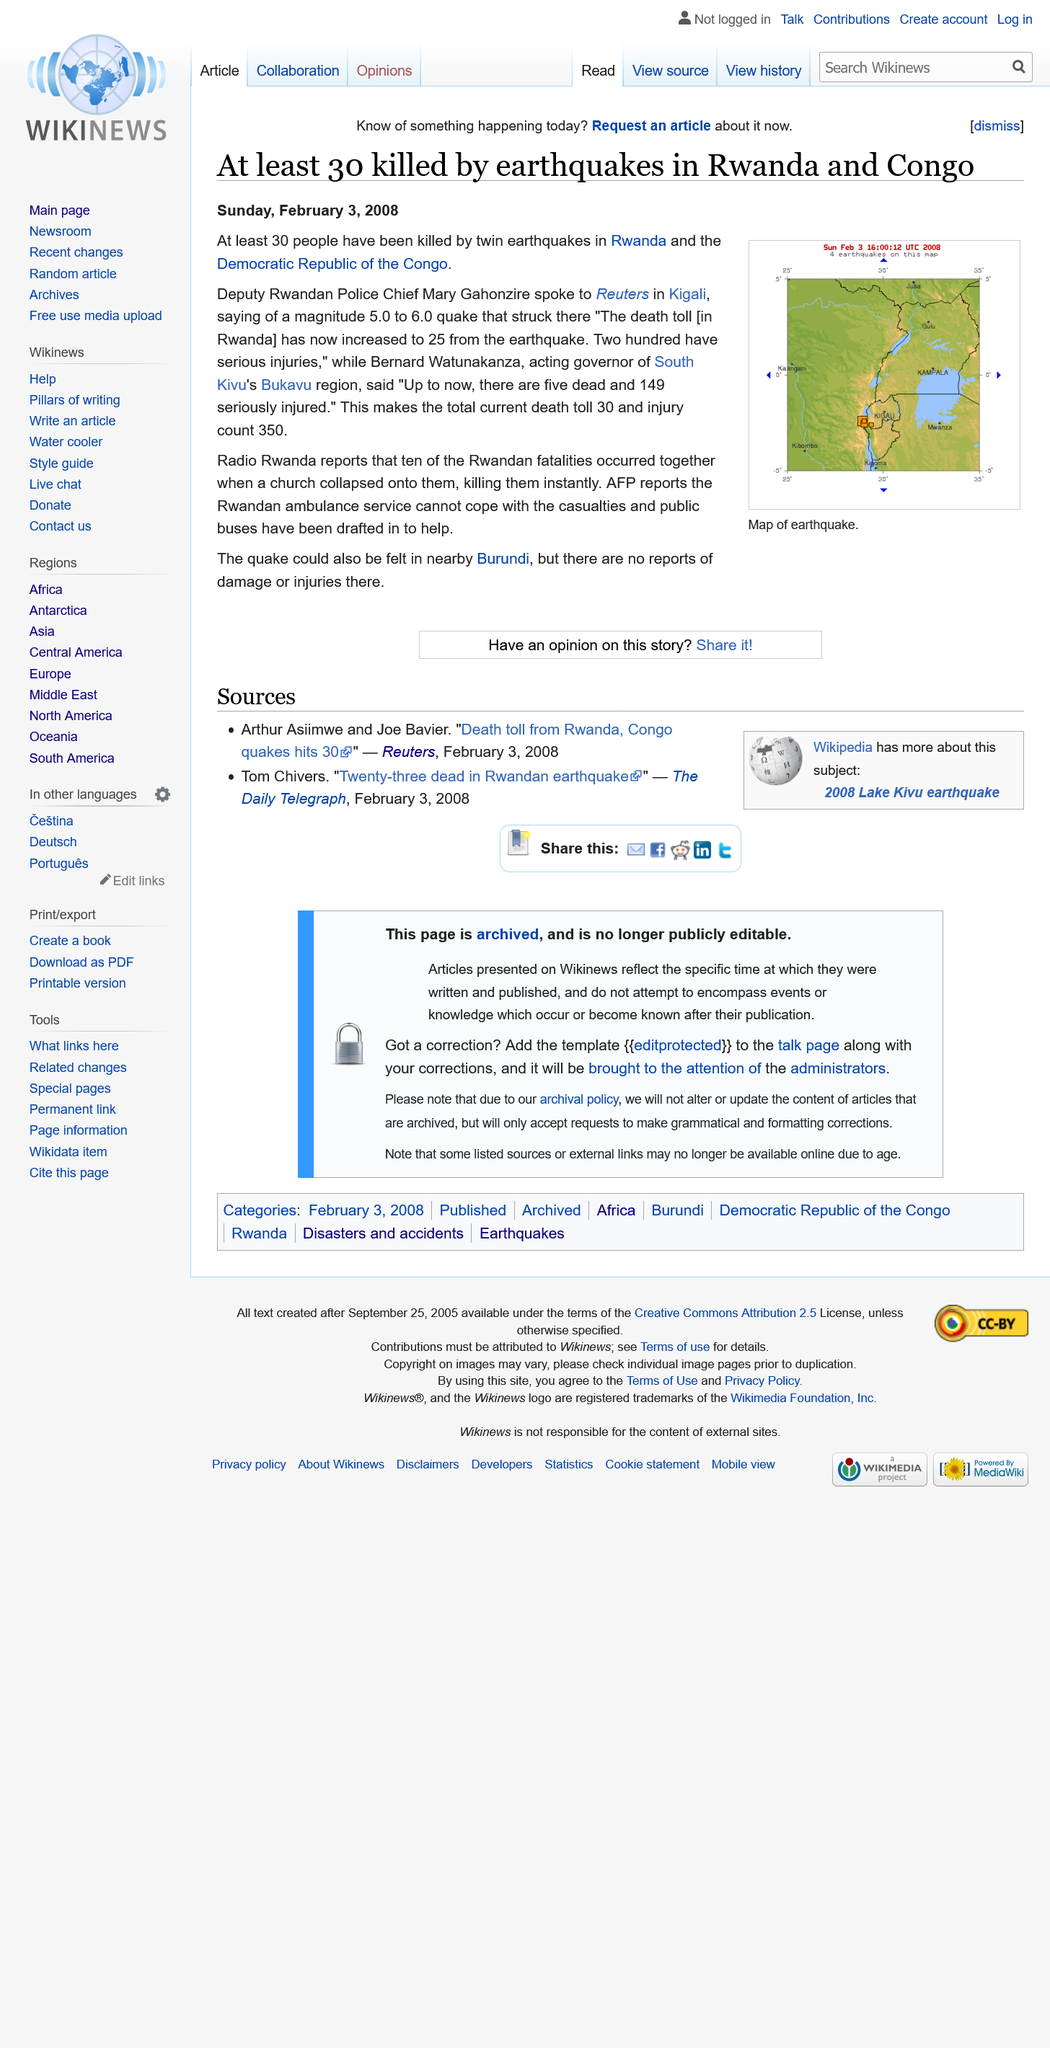Identify some key points in this picture. In the earthquakes in Rwanda and Congo, a total of 350 people were injured. At least 30 individuals lost their lives in the earthquakes that occurred in Rwanda and Congo. The image depicts a map of earthquakes, revealing the locations and magnitude of seismic activity around the world. 